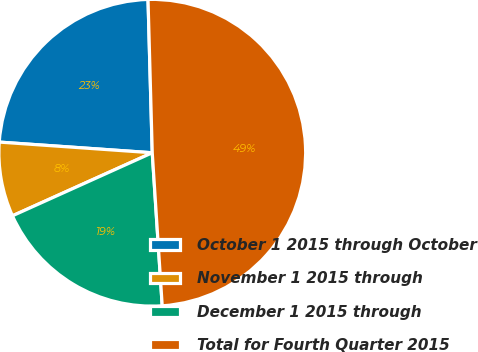<chart> <loc_0><loc_0><loc_500><loc_500><pie_chart><fcel>October 1 2015 through October<fcel>November 1 2015 through<fcel>December 1 2015 through<fcel>Total for Fourth Quarter 2015<nl><fcel>23.45%<fcel>7.85%<fcel>19.29%<fcel>49.4%<nl></chart> 